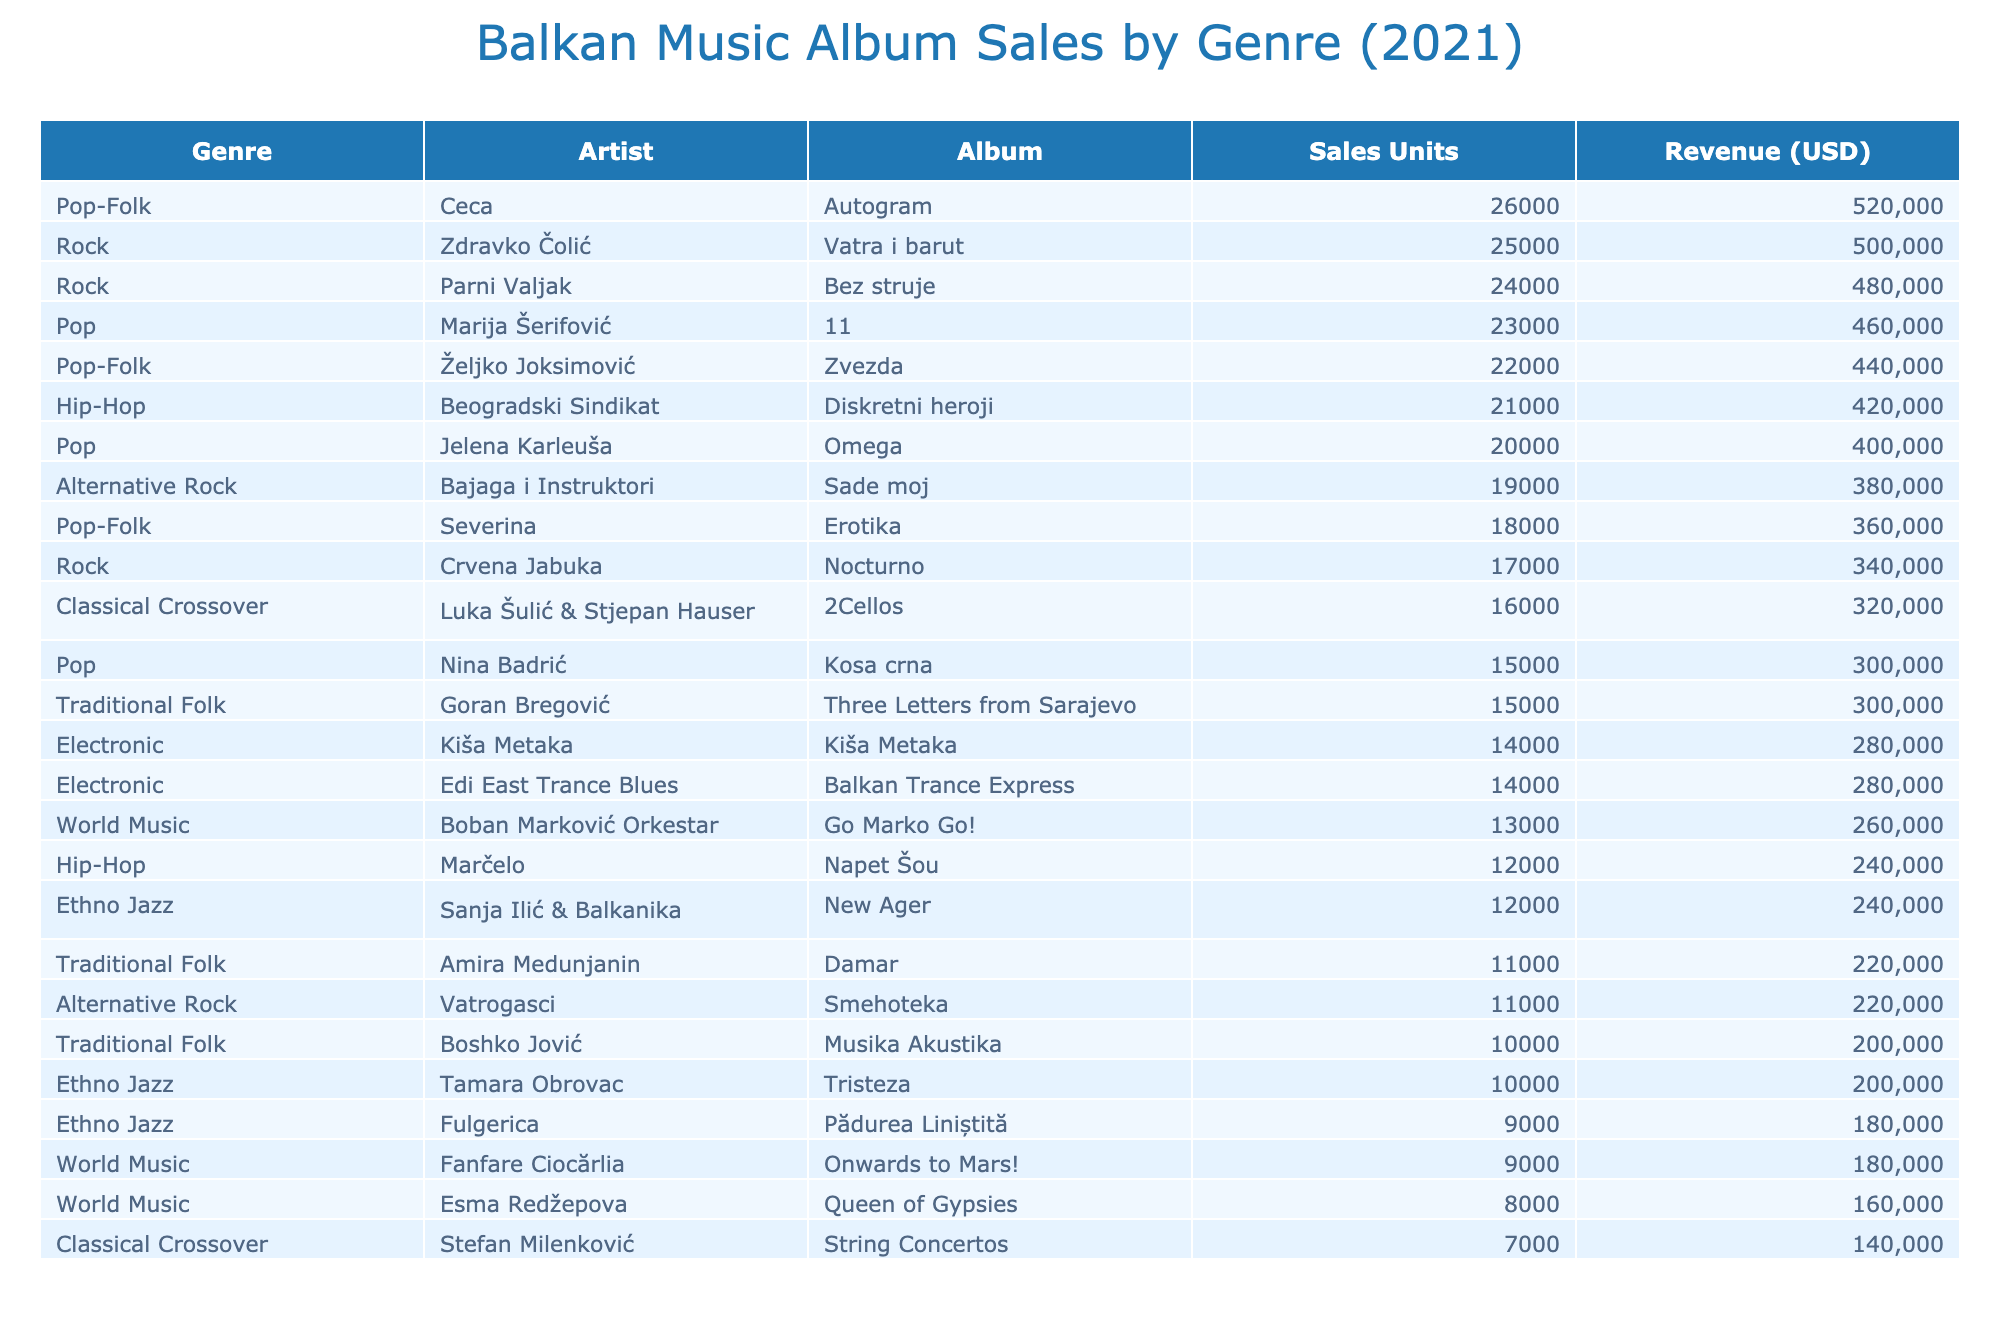What was the total sales for the album "Erotika" by Severina? The sales units for "Erotika" by Severina are listed as 18000. To find the total sales, we simply refer to the table.
Answer: 18000 Which genre had the highest revenue, and what was that revenue? By comparing the revenue values from all genres, we see that the genre Rock, specifically the album "Vatra i barut" by Zdravko Čolić, had the highest revenue of 500000.
Answer: Rock: 500000 How many units did Pop-Folk albums sell together? To find the total units sold for Pop-Folk albums, we sum the sales units of "Erotika" (18000) and "Autogram" (26000), which gives us 18000 + 26000 = 44000.
Answer: 44000 Is it true that the album "Damar" by Amira Medunjanin had more sales than the album "Tristeza" by Tamara Obrovac? By comparing the sales units, "Damar" had 11000 units sold, and "Tristeza" had 10000 units sold. Since 11000 is greater than 10000, the statement is true.
Answer: Yes What is the average revenue for albums classified as World Music? To find the average revenue for World Music, we take the total revenue values from "Queen of Gypsies" (160000), "Go Marko Go!" (260000), and "Onwards to Mars!" (180000), which totals 600000. Then we divide by the number of albums (3) to find the average: 600000/3 = 200000.
Answer: 200000 What is the difference in sales units between the highest-selling and lowest-selling albums? The highest-selling album is "Vatra i barut" with 25000 sales units, and the lowest-selling album is "Go Marko Go!" with 8000 sales units. The difference is calculated as 25000 - 8000 = 17000.
Answer: 17000 How many more sales units did alternative rock albums sell compared to traditional folk albums? The sales units for Alternative Rock (Sade moj: 19000) and Traditional Folk (Musika Akustika: 10000) are compared. The difference is 19000 - 10000 = 9000 more units.
Answer: 9000 Is the total revenue for "11" by Marija Šerifović equal to the revenue for "Omega" by Jelena Karleuša? The revenue for "11" is 460000, while for "Omega" it is also 400000. Since these amounts are not equal, the statement is false.
Answer: No 